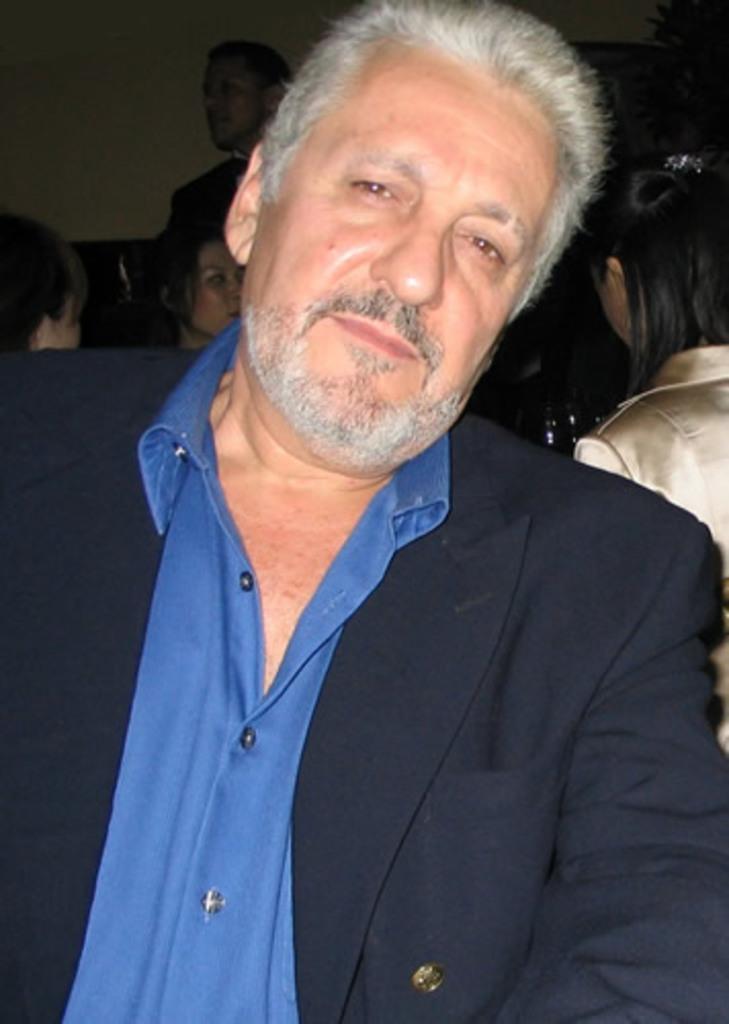Could you give a brief overview of what you see in this image? There is a man wearing a coat and blue shirt. In the back there are many people. 